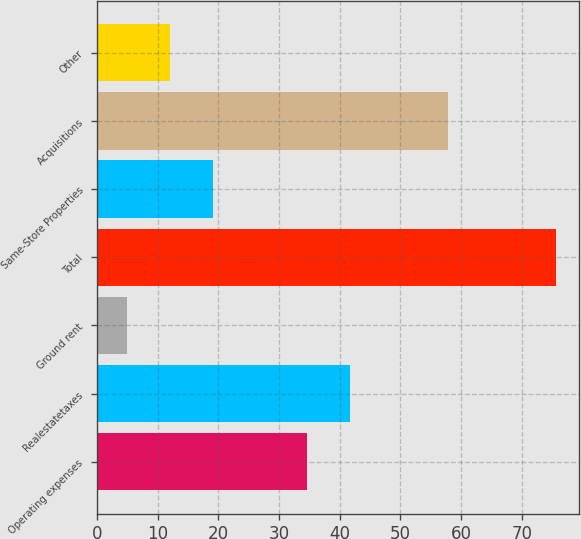<chart> <loc_0><loc_0><loc_500><loc_500><bar_chart><fcel>Operating expenses<fcel>Realestatetaxes<fcel>Ground rent<fcel>Total<fcel>Same-Store Properties<fcel>Acquisitions<fcel>Other<nl><fcel>34.6<fcel>41.66<fcel>5<fcel>75.6<fcel>19.12<fcel>57.9<fcel>12.06<nl></chart> 